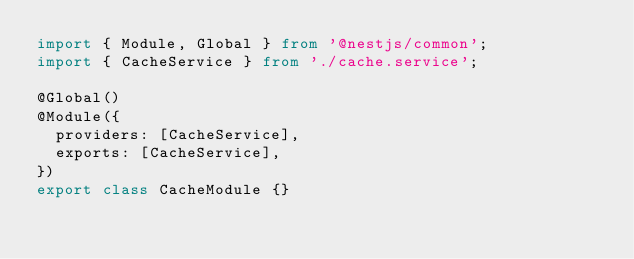<code> <loc_0><loc_0><loc_500><loc_500><_TypeScript_>import { Module, Global } from '@nestjs/common';
import { CacheService } from './cache.service';

@Global()
@Module({
  providers: [CacheService],
  exports: [CacheService],
})
export class CacheModule {}
</code> 